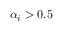<formula> <loc_0><loc_0><loc_500><loc_500>\alpha _ { i } > 0 . 5</formula> 